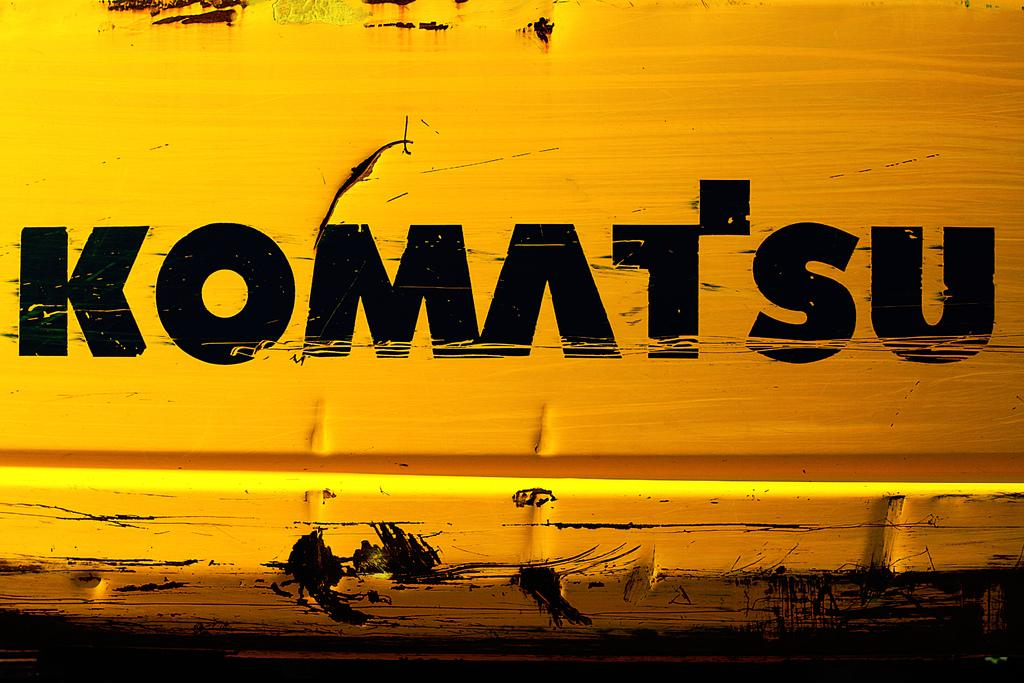<image>
Write a terse but informative summary of the picture. Black letters which say KOMATSU are seen on a yellow background here. 